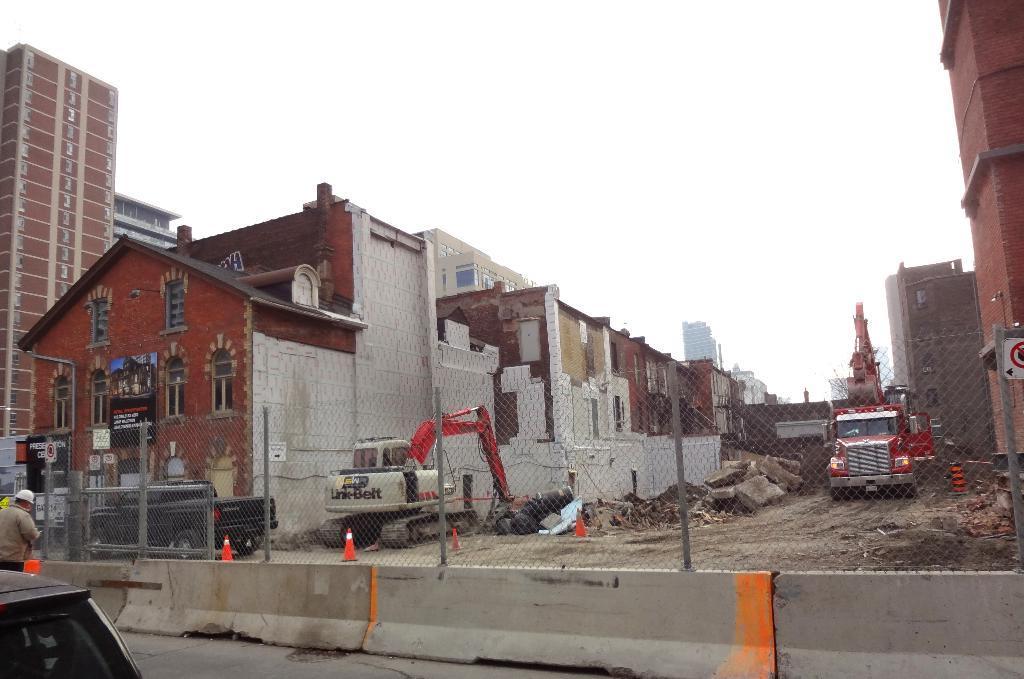In one or two sentences, can you explain what this image depicts? At the bottom of the image there is a fencing. Behind the fencing there are few vehicles like cranes. And also there are buildings with walls, windows and roofs. At the top of the image there is a sky. 